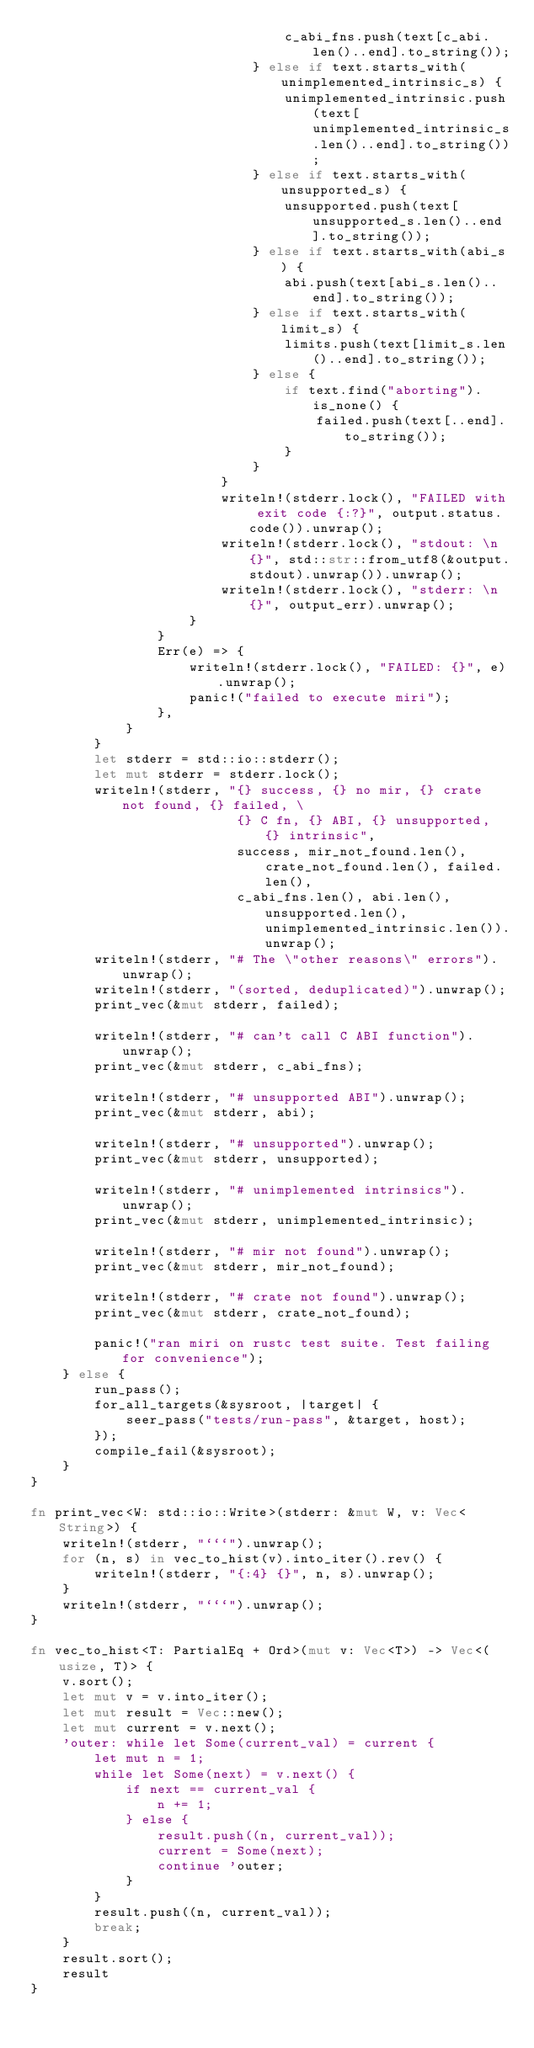<code> <loc_0><loc_0><loc_500><loc_500><_Rust_>                                c_abi_fns.push(text[c_abi.len()..end].to_string());
                            } else if text.starts_with(unimplemented_intrinsic_s) {
                                unimplemented_intrinsic.push(text[unimplemented_intrinsic_s.len()..end].to_string());
                            } else if text.starts_with(unsupported_s) {
                                unsupported.push(text[unsupported_s.len()..end].to_string());
                            } else if text.starts_with(abi_s) {
                                abi.push(text[abi_s.len()..end].to_string());
                            } else if text.starts_with(limit_s) {
                                limits.push(text[limit_s.len()..end].to_string());
                            } else {
                                if text.find("aborting").is_none() {
                                    failed.push(text[..end].to_string());
                                }
                            }
                        }
                        writeln!(stderr.lock(), "FAILED with exit code {:?}", output.status.code()).unwrap();
                        writeln!(stderr.lock(), "stdout: \n {}", std::str::from_utf8(&output.stdout).unwrap()).unwrap();
                        writeln!(stderr.lock(), "stderr: \n {}", output_err).unwrap();
                    }
                }
                Err(e) => {
                    writeln!(stderr.lock(), "FAILED: {}", e).unwrap();
                    panic!("failed to execute miri");
                },
            }
        }
        let stderr = std::io::stderr();
        let mut stderr = stderr.lock();
        writeln!(stderr, "{} success, {} no mir, {} crate not found, {} failed, \
                          {} C fn, {} ABI, {} unsupported, {} intrinsic",
                          success, mir_not_found.len(), crate_not_found.len(), failed.len(),
                          c_abi_fns.len(), abi.len(), unsupported.len(), unimplemented_intrinsic.len()).unwrap();
        writeln!(stderr, "# The \"other reasons\" errors").unwrap();
        writeln!(stderr, "(sorted, deduplicated)").unwrap();
        print_vec(&mut stderr, failed);

        writeln!(stderr, "# can't call C ABI function").unwrap();
        print_vec(&mut stderr, c_abi_fns);

        writeln!(stderr, "# unsupported ABI").unwrap();
        print_vec(&mut stderr, abi);

        writeln!(stderr, "# unsupported").unwrap();
        print_vec(&mut stderr, unsupported);

        writeln!(stderr, "# unimplemented intrinsics").unwrap();
        print_vec(&mut stderr, unimplemented_intrinsic);

        writeln!(stderr, "# mir not found").unwrap();
        print_vec(&mut stderr, mir_not_found);

        writeln!(stderr, "# crate not found").unwrap();
        print_vec(&mut stderr, crate_not_found);

        panic!("ran miri on rustc test suite. Test failing for convenience");
    } else {
        run_pass();
        for_all_targets(&sysroot, |target| {
            seer_pass("tests/run-pass", &target, host);
        });
        compile_fail(&sysroot);
    }
}

fn print_vec<W: std::io::Write>(stderr: &mut W, v: Vec<String>) {
    writeln!(stderr, "```").unwrap();
    for (n, s) in vec_to_hist(v).into_iter().rev() {
        writeln!(stderr, "{:4} {}", n, s).unwrap();
    }
    writeln!(stderr, "```").unwrap();
}

fn vec_to_hist<T: PartialEq + Ord>(mut v: Vec<T>) -> Vec<(usize, T)> {
    v.sort();
    let mut v = v.into_iter();
    let mut result = Vec::new();
    let mut current = v.next();
    'outer: while let Some(current_val) = current {
        let mut n = 1;
        while let Some(next) = v.next() {
            if next == current_val {
                n += 1;
            } else {
                result.push((n, current_val));
                current = Some(next);
                continue 'outer;
            }
        }
        result.push((n, current_val));
        break;
    }
    result.sort();
    result
}
</code> 